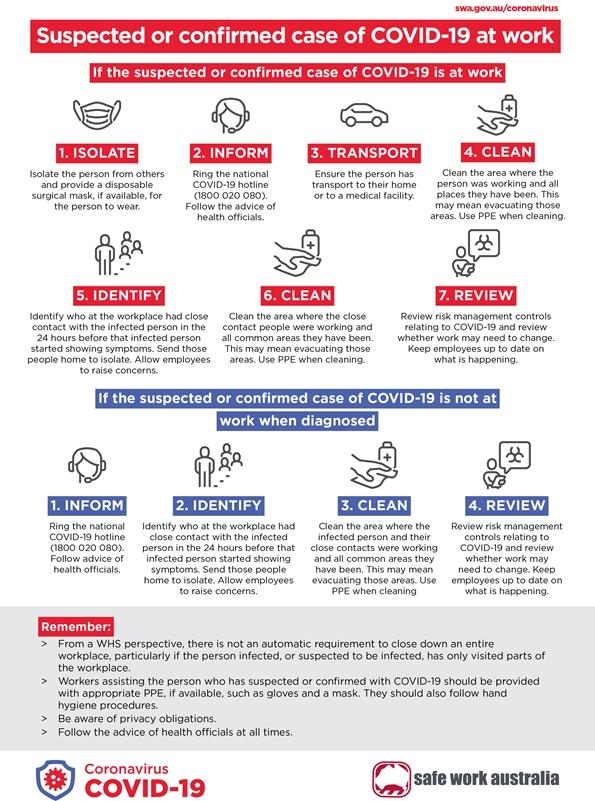Indicate a few pertinent items in this graphic. In cases where suspected, it is common to do 4 points both at work and not at work. Providing a disposable surgical mask is an essential step in the process of isolation, which aims to prevent the spread of infectious diseases. Workers assisting individuals who are suspected or confirmed to have COVID-19 are required to wear personal protective equipment (PPE), including gloves and masks, to minimize the risk of exposure to the virus. 